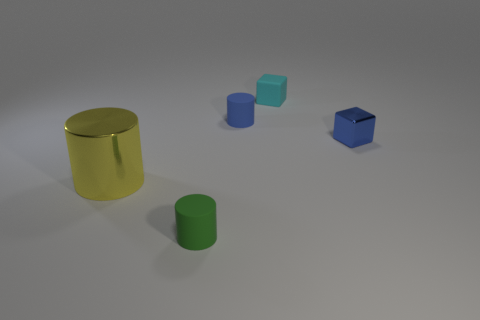Add 5 small purple rubber blocks. How many objects exist? 10 Subtract all cylinders. How many objects are left? 2 Add 3 big brown matte cubes. How many big brown matte cubes exist? 3 Subtract 0 gray cylinders. How many objects are left? 5 Subtract all small cylinders. Subtract all rubber cubes. How many objects are left? 2 Add 2 green cylinders. How many green cylinders are left? 3 